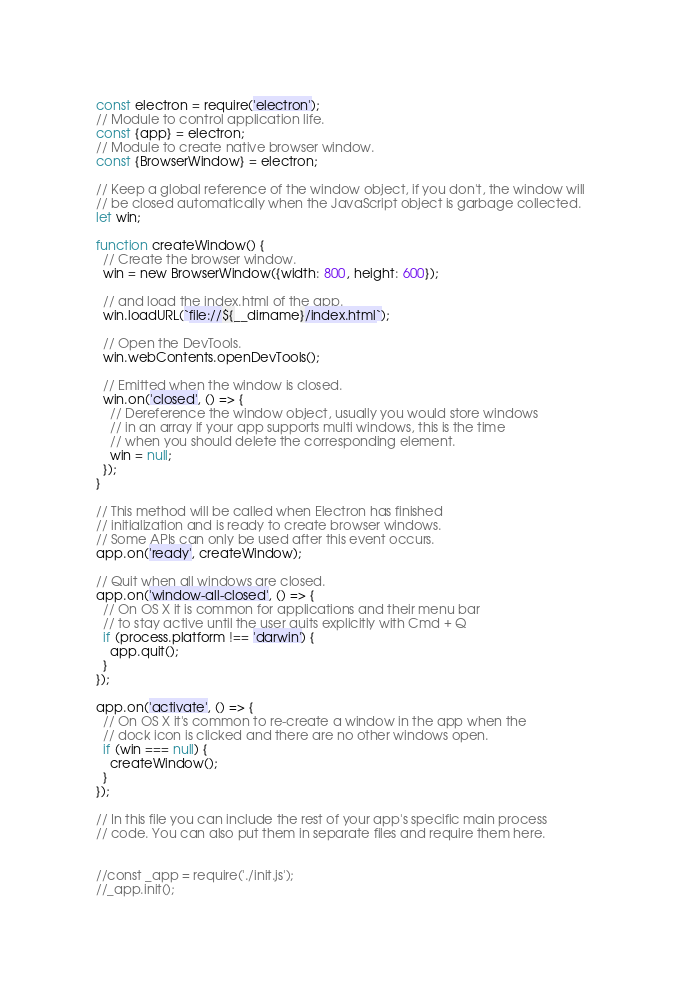Convert code to text. <code><loc_0><loc_0><loc_500><loc_500><_JavaScript_>const electron = require('electron');
// Module to control application life.
const {app} = electron;
// Module to create native browser window.
const {BrowserWindow} = electron;

// Keep a global reference of the window object, if you don't, the window will
// be closed automatically when the JavaScript object is garbage collected.
let win;

function createWindow() {
  // Create the browser window.
  win = new BrowserWindow({width: 800, height: 600});

  // and load the index.html of the app.
  win.loadURL(`file://${__dirname}/index.html`);

  // Open the DevTools.
  win.webContents.openDevTools();

  // Emitted when the window is closed.
  win.on('closed', () => {
    // Dereference the window object, usually you would store windows
    // in an array if your app supports multi windows, this is the time
    // when you should delete the corresponding element.
    win = null;
  });
}

// This method will be called when Electron has finished
// initialization and is ready to create browser windows.
// Some APIs can only be used after this event occurs.
app.on('ready', createWindow);

// Quit when all windows are closed.
app.on('window-all-closed', () => {
  // On OS X it is common for applications and their menu bar
  // to stay active until the user quits explicitly with Cmd + Q
  if (process.platform !== 'darwin') {
    app.quit();
  }
});

app.on('activate', () => {
  // On OS X it's common to re-create a window in the app when the
  // dock icon is clicked and there are no other windows open.
  if (win === null) {
    createWindow();
  }
});

// In this file you can include the rest of your app's specific main process
// code. You can also put them in separate files and require them here.


//const _app = require('./init.js');
//_app.init();
</code> 